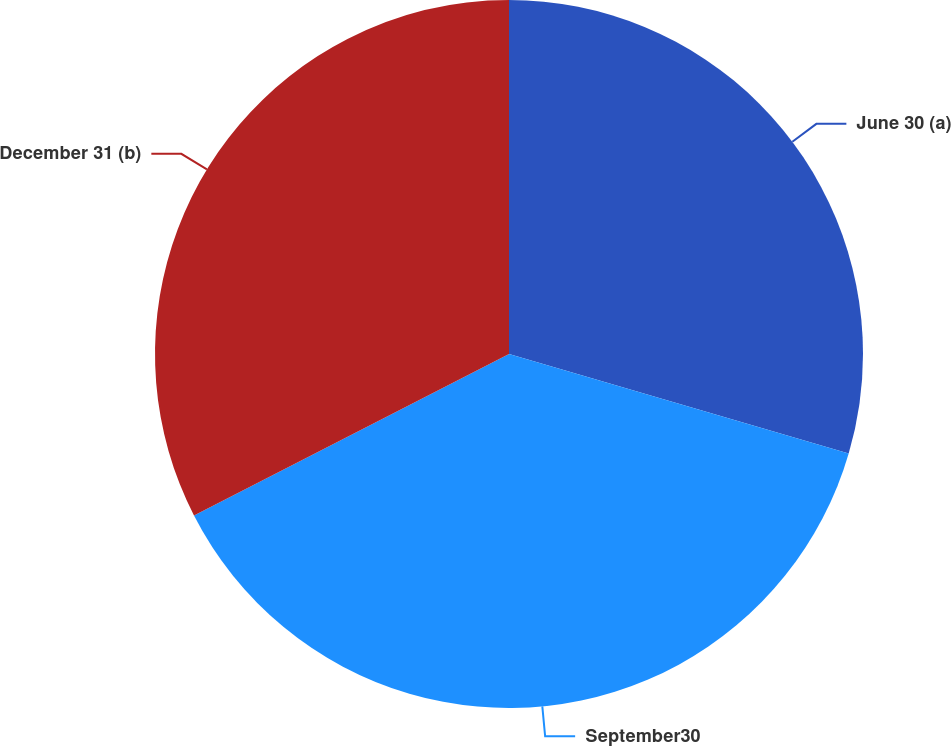Convert chart to OTSL. <chart><loc_0><loc_0><loc_500><loc_500><pie_chart><fcel>June 30 (a)<fcel>September30<fcel>December 31 (b)<nl><fcel>29.54%<fcel>37.92%<fcel>32.54%<nl></chart> 